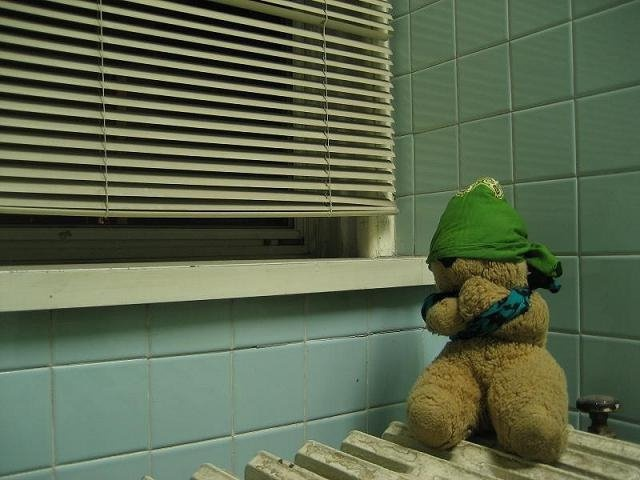Describe the objects in this image and their specific colors. I can see a teddy bear in darkgreen, olive, and black tones in this image. 